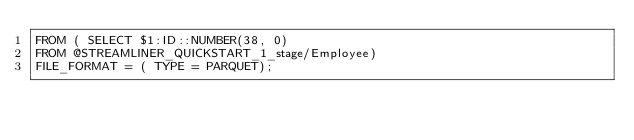<code> <loc_0><loc_0><loc_500><loc_500><_SQL_>FROM ( SELECT $1:ID::NUMBER(38, 0)
FROM @STREAMLINER_QUICKSTART_1_stage/Employee)
FILE_FORMAT = ( TYPE = PARQUET);</code> 